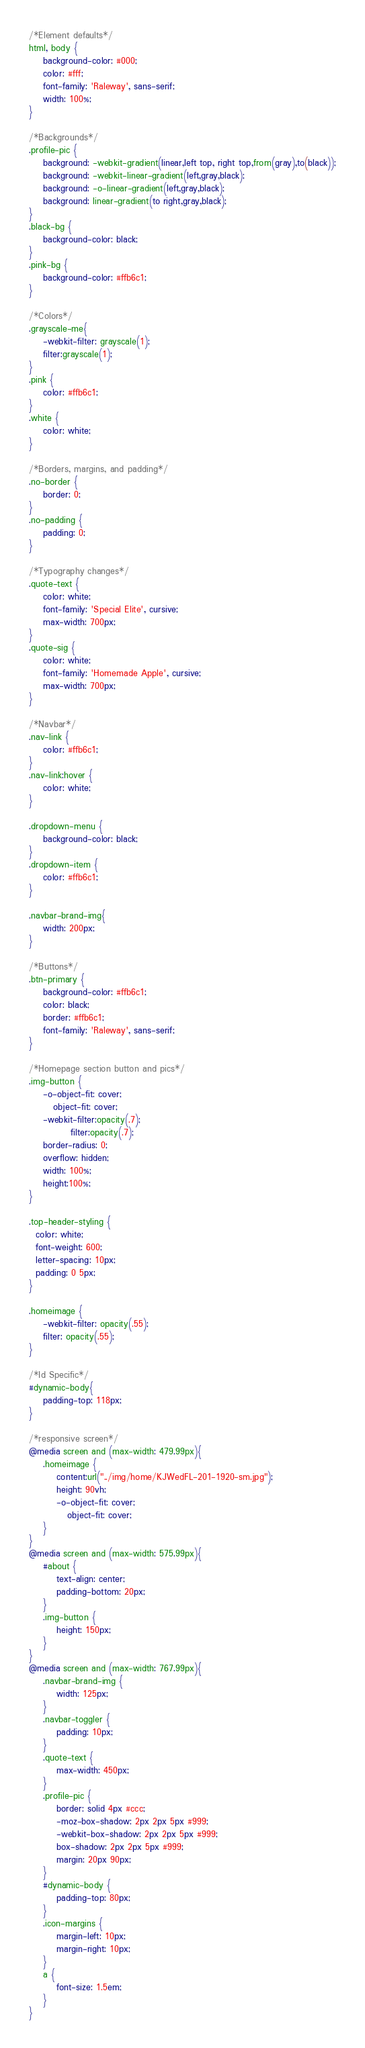Convert code to text. <code><loc_0><loc_0><loc_500><loc_500><_CSS_>/*Element defaults*/
html, body {
	background-color: #000;
	color: #fff;
	font-family: 'Raleway', sans-serif;
	width: 100%;
}

/*Backgrounds*/
.profile-pic {
	background: -webkit-gradient(linear,left top, right top,from(gray),to(black));
	background: -webkit-linear-gradient(left,gray,black);
	background: -o-linear-gradient(left,gray,black);
	background: linear-gradient(to right,gray,black);
}
.black-bg {
	background-color: black;
}
.pink-bg {
	background-color: #ffb6c1;
}

/*Colors*/
.grayscale-me{
	-webkit-filter: grayscale(1);
	filter:grayscale(1);
}
.pink {
	color: #ffb6c1;
}
.white {
	color: white;
}

/*Borders, margins, and padding*/
.no-border {
	border: 0;
}
.no-padding {
	padding: 0;
}

/*Typography changes*/
.quote-text {
    color: white;
    font-family: 'Special Elite', cursive;
    max-width: 700px;
}
.quote-sig {
    color: white;
    font-family: 'Homemade Apple', cursive;
    max-width: 700px;
}

/*Navbar*/
.nav-link {
	color: #ffb6c1;
}
.nav-link:hover {
	color: white;
}

.dropdown-menu {
	background-color: black;
}
.dropdown-item {
	color: #ffb6c1;
}

.navbar-brand-img{
	width: 200px;
}

/*Buttons*/
.btn-primary {
	background-color: #ffb6c1;
	color: black;
	border: #ffb6c1;
	font-family: 'Raleway', sans-serif;
}

/*Homepage section button and pics*/
.img-button {
	-o-object-fit: cover;
	   object-fit: cover;
	-webkit-filter:opacity(.7);
	        filter:opacity(.7);
	border-radius: 0;
	overflow: hidden;
	width: 100%;
	height:100%;
}

.top-header-styling {
  color: white;
  font-weight: 600;
  letter-spacing: 10px;
  padding: 0 5px;
}

.homeimage {
	-webkit-filter: opacity(.55);
	filter: opacity(.55);
}

/*Id Specific*/
#dynamic-body{
	padding-top: 118px;
}

/*responsive screen*/
@media screen and (max-width: 479.99px){
	.homeimage {
		content:url("../img/home/KJWedFL-201-1920-sm.jpg");
		height: 90vh;
		-o-object-fit: cover;
		   object-fit: cover;
	}
}
@media screen and (max-width: 575.99px){
	#about {
		text-align: center;
		padding-bottom: 20px;
	}
	.img-button {
		height: 150px;
	}
}
@media screen and (max-width: 767.99px){
	.navbar-brand-img {
		width: 125px;
	}
	.navbar-toggler {
		padding: 10px;
	}
	.quote-text {
		max-width: 450px;
	}
	.profile-pic {
		border: solid 4px #ccc;
		-moz-box-shadow: 2px 2px 5px #999;
    	-webkit-box-shadow: 2px 2px 5px #999;
        box-shadow: 2px 2px 5px #999;
		margin: 20px 90px;
	}
	#dynamic-body {
		padding-top: 80px;
	}
	.icon-margins {
		margin-left: 10px;
		margin-right: 10px;
	}
	a {
		font-size: 1.5em;
	}
}

</code> 